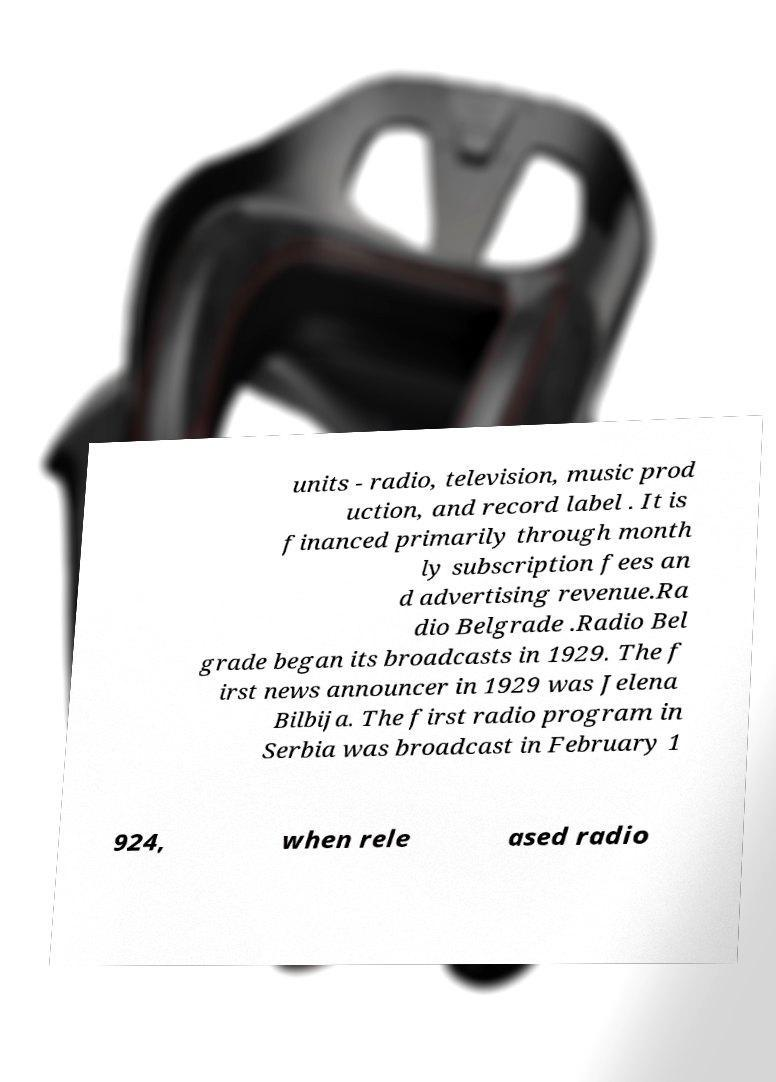I need the written content from this picture converted into text. Can you do that? units - radio, television, music prod uction, and record label . It is financed primarily through month ly subscription fees an d advertising revenue.Ra dio Belgrade .Radio Bel grade began its broadcasts in 1929. The f irst news announcer in 1929 was Jelena Bilbija. The first radio program in Serbia was broadcast in February 1 924, when rele ased radio 